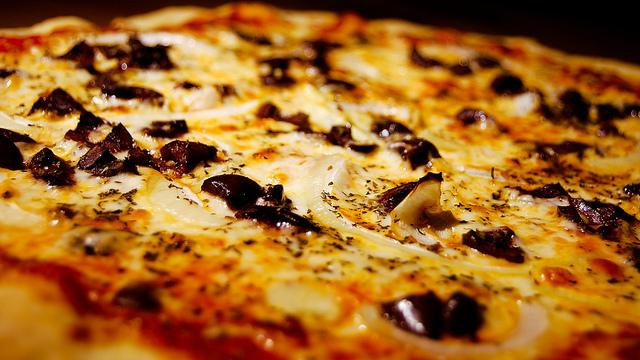Do you person preparing the food?
Give a very brief answer. No. Is this an Italian dish?
Write a very short answer. Yes. Is this a chocolate chip cookie?
Concise answer only. No. 